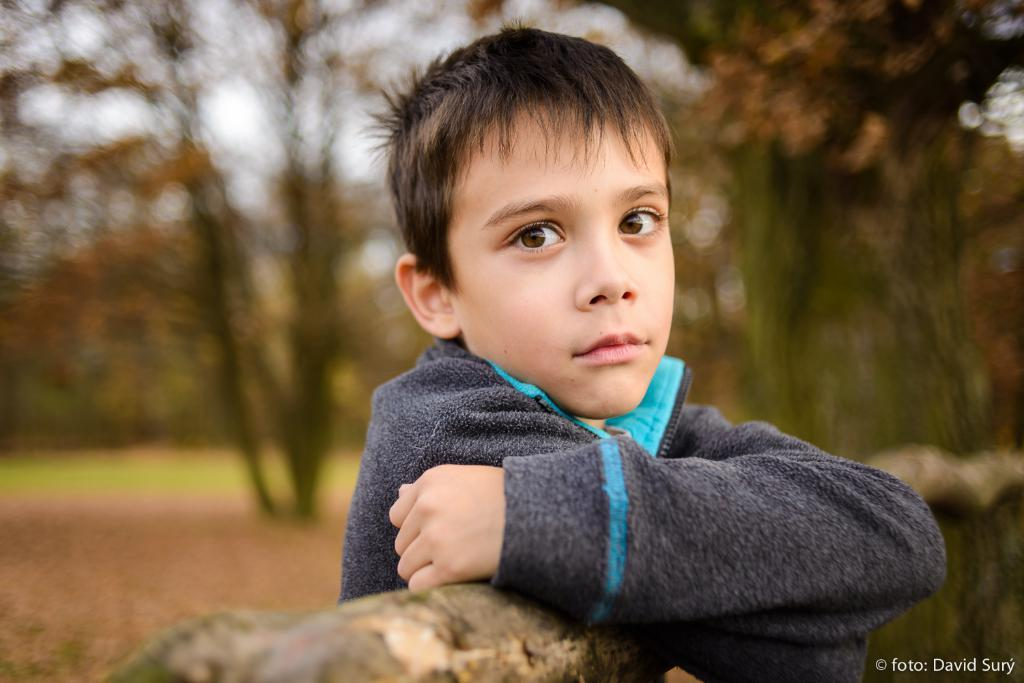Who or what is present in the image? There is a person in the image. What is the primary object or feature in the background? There is a wall in the image. Is there any text visible in the image? Yes, there is text in the bottom right corner of the image. How would you describe the background of the image? The background of the image is blurred. How many legs does the sponge have in the image? There is no sponge present in the image, so it is not possible to determine the number of legs it might have. 